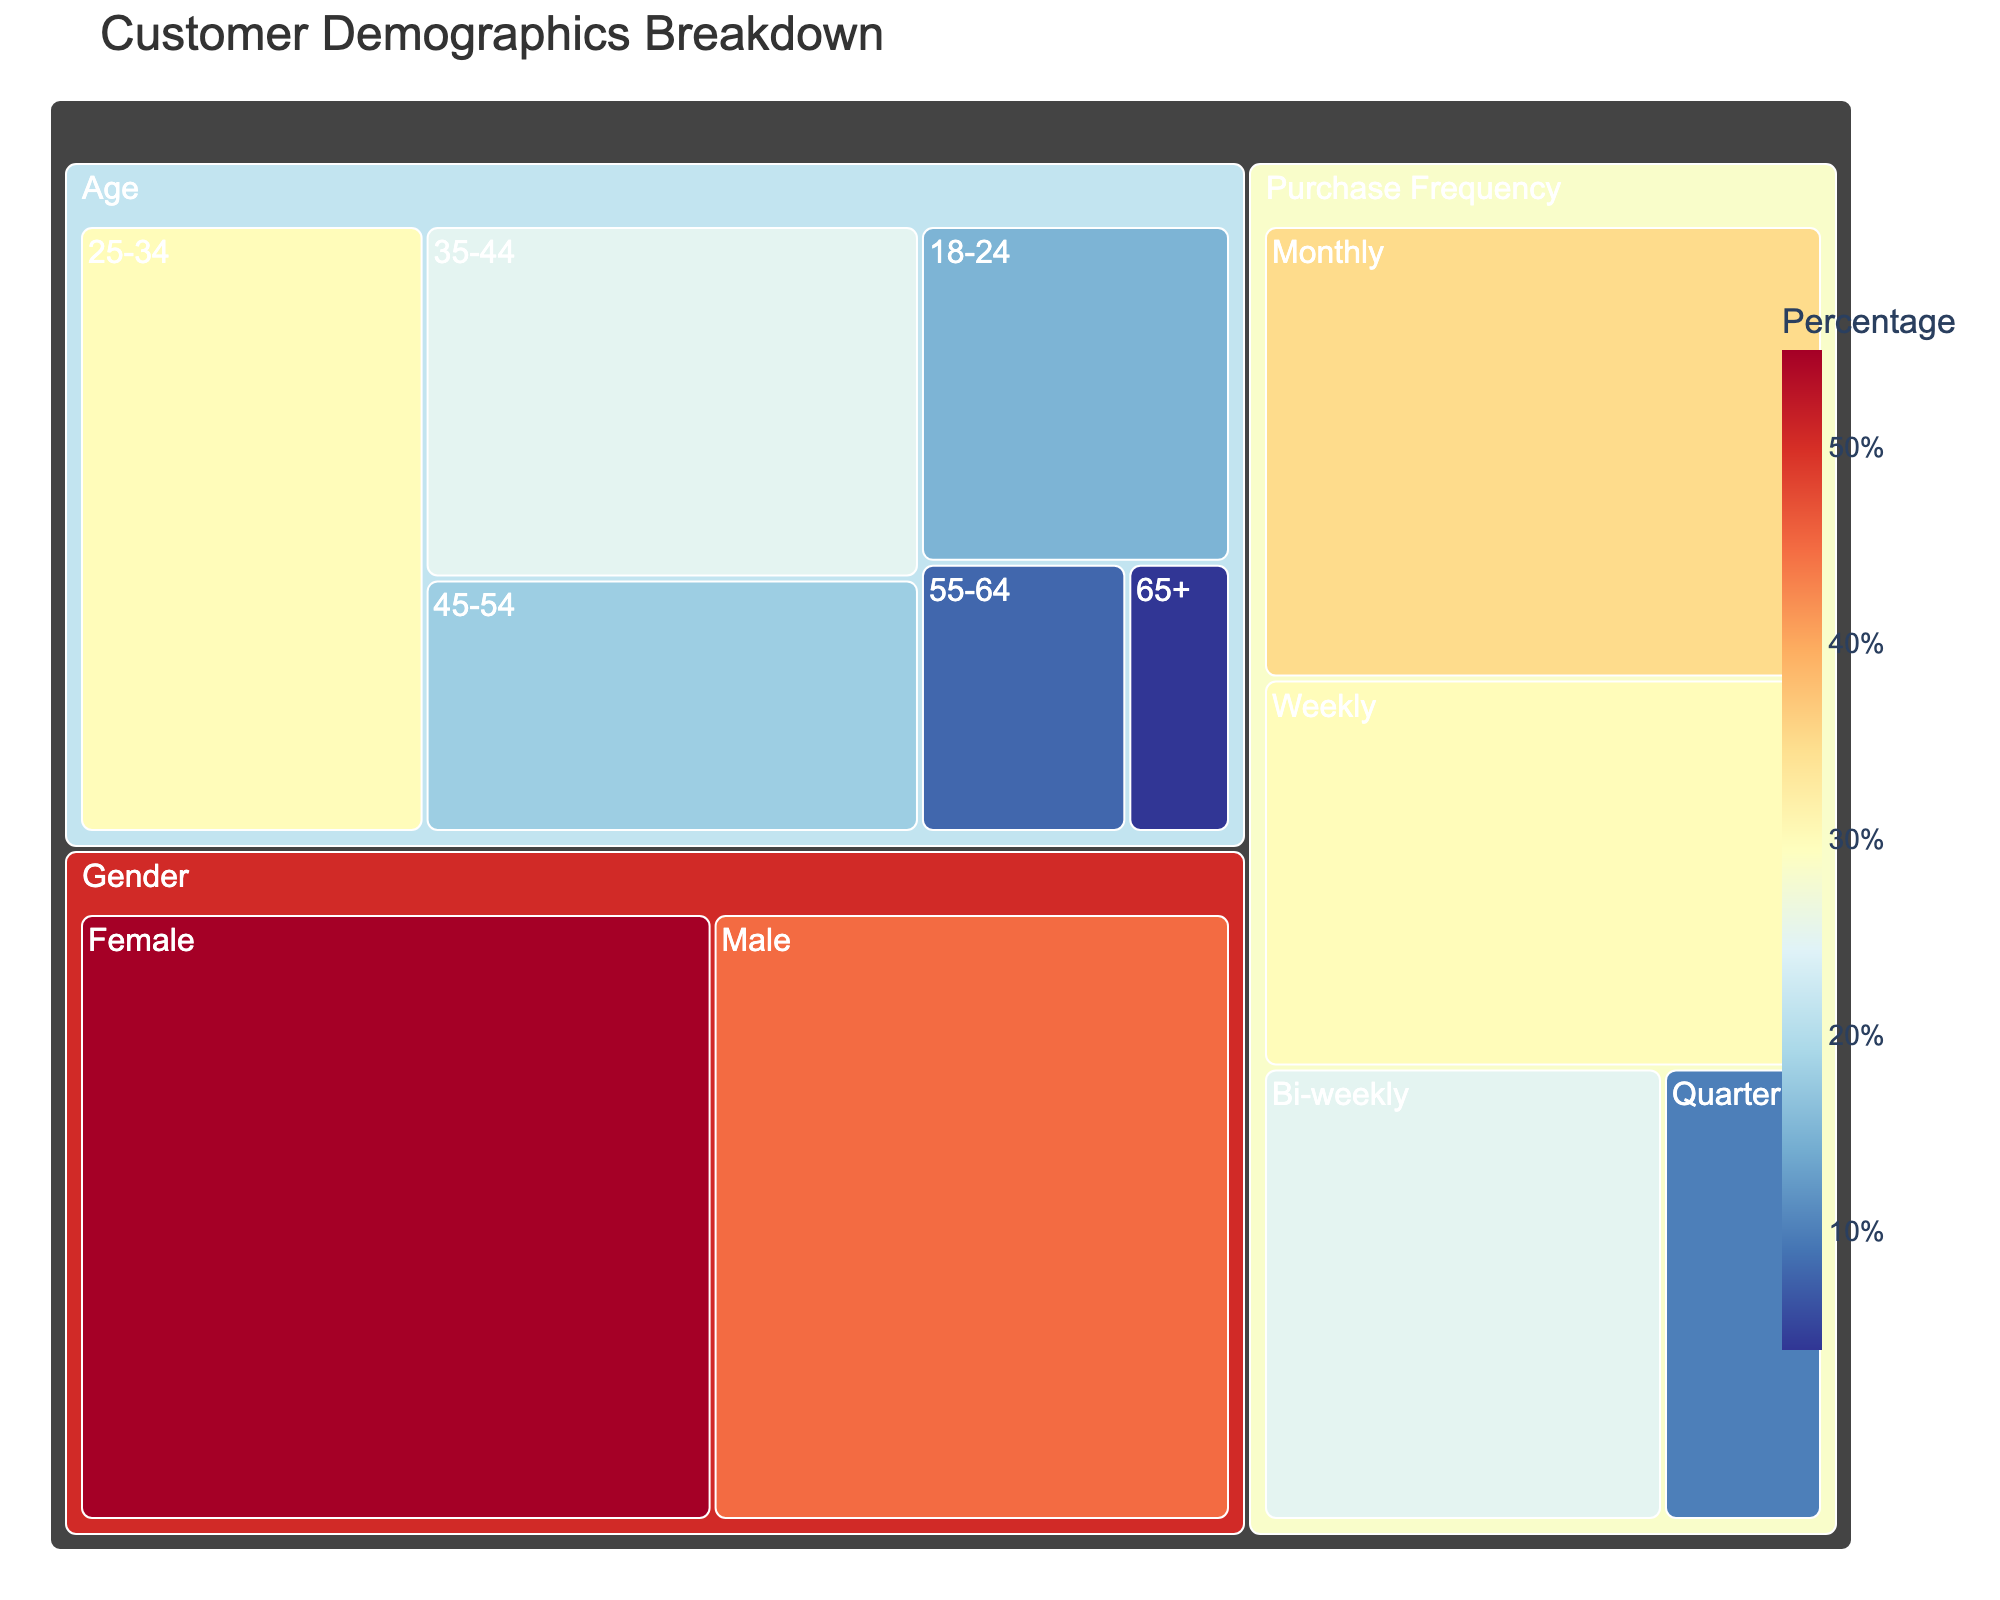How many age groups are represented in the plot? There are distinct categories under the Age section of the treemap. By visually scanning the age-related tiles, we can count the different age groups. The groups are 18-24, 25-34, 35-44, 45-54, 55-64, and 65+.
Answer: 6 Which gender category has a higher value? By comparing the size and value labeling on the gender tiles, the Female category has a value of 55 and the Male category has a value of 45.
Answer: Female What is the total percentage of purchases made bi-weekly and monthly? We need to sum the values for purchases made Bi-weekly and Monthly. From the figure, Bi-weekly has a value of 25 and Monthly has a value of 35. Adding these up gives us 25 + 35.
Answer: 60 Which age group has the smallest value? By examining the tiles under the Age category and looking for the smallest number, the 65+ age group has the smallest value, which is 4.
Answer: 65+ Compare the values of weekly and quarterly purchase frequency. Which is higher and by how much? To compare, we see that Weekly purchases have a value of 30 and Quarterly purchases have a value of 10. The difference between them is 30 - 10.
Answer: Weekly by 20 What is the average value of all age groups combined? We add up all the values from the age groups (15, 30, 25, 18, 8, 4) and then divide by the number of age groups. The sum is 15 + 30 + 25 + 18 + 8 + 4 = 100, and there are 6 age groups. So, 100 / 6.
Answer: 16.67 Which purchase frequency category encompasses the highest value? By comparing the values under the Purchase Frequency section, the Monthly category has the highest value at 35.
Answer: Monthly What percentage of customers are between the ages of 35 to 54? We need to add the values for the 35-44 and 45-54 age groups. This results in 25 + 18.
Answer: 43 Compare the values of the Male and Bi-weekly categories. Which is higher and by how much? The Male category has a value of 45, and the Bi-weekly purchase frequency has a value of 25. The difference is 45 - 25.
Answer: Male by 20 